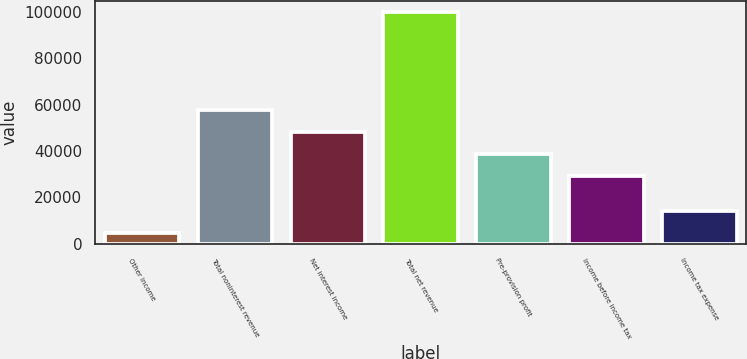Convert chart to OTSL. <chart><loc_0><loc_0><loc_500><loc_500><bar_chart><fcel>Other income<fcel>Total noninterest revenue<fcel>Net interest income<fcel>Total net revenue<fcel>Pre-provision profit<fcel>Income before income tax<fcel>Income tax expense<nl><fcel>4608<fcel>57829.7<fcel>48313.8<fcel>99767<fcel>38797.9<fcel>29282<fcel>14123.9<nl></chart> 